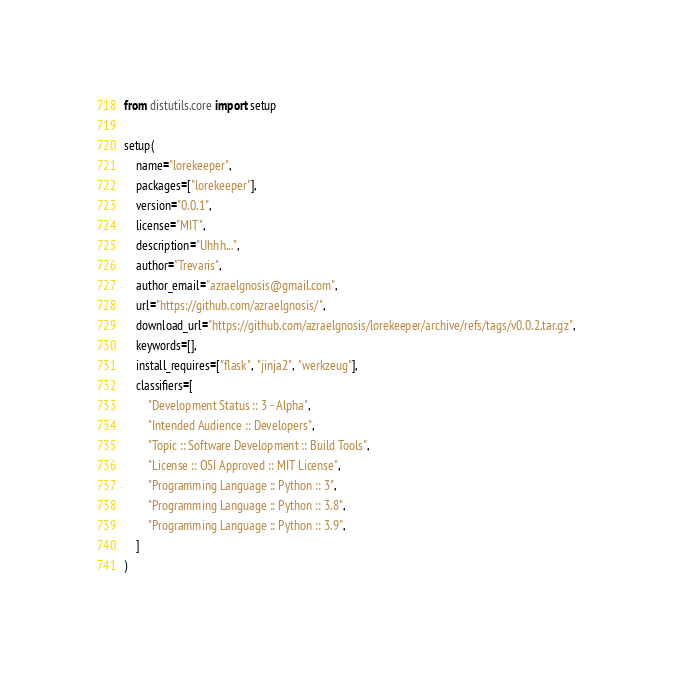Convert code to text. <code><loc_0><loc_0><loc_500><loc_500><_Python_>from distutils.core import setup

setup(
    name="lorekeeper",
    packages=["lorekeeper"],
    version="0.0.1",
    license="MIT",
    description="Uhhh...",
    author="Trevaris",
    author_email="azraelgnosis@gmail.com",
    url="https://github.com/azraelgnosis/",
    download_url="https://github.com/azraelgnosis/lorekeeper/archive/refs/tags/v0.0.2.tar.gz",
    keywords=[],
    install_requires=["flask", "jinja2", "werkzeug"],
    classifiers=[
        "Development Status :: 3 - Alpha",
        "Intended Audience :: Developers",
        "Topic :: Software Development :: Build Tools",
        "License :: OSI Approved :: MIT License",
        "Programming Language :: Python :: 3",
        "Programming Language :: Python :: 3.8",
        "Programming Language :: Python :: 3.9",
    ]
)</code> 